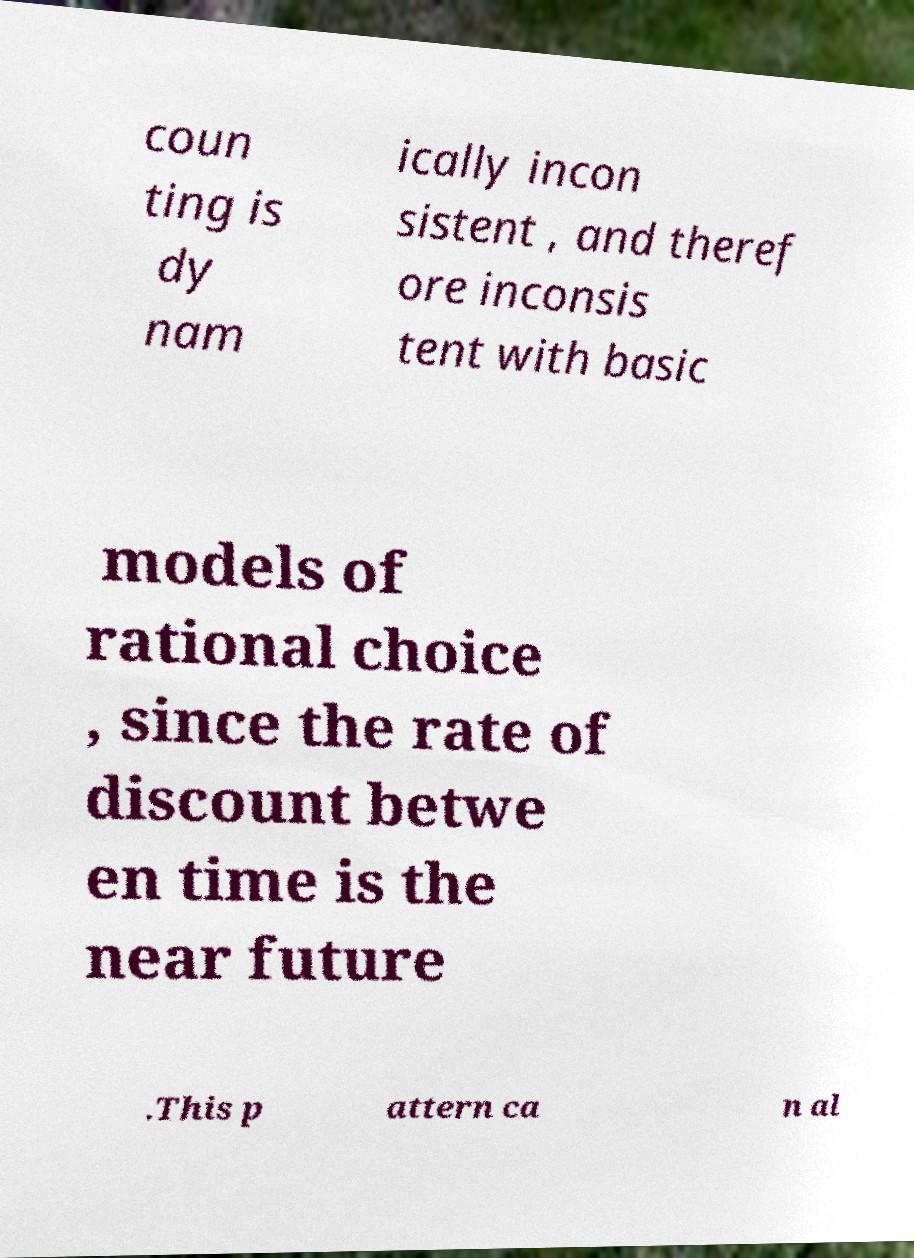I need the written content from this picture converted into text. Can you do that? coun ting is dy nam ically incon sistent , and theref ore inconsis tent with basic models of rational choice , since the rate of discount betwe en time is the near future .This p attern ca n al 